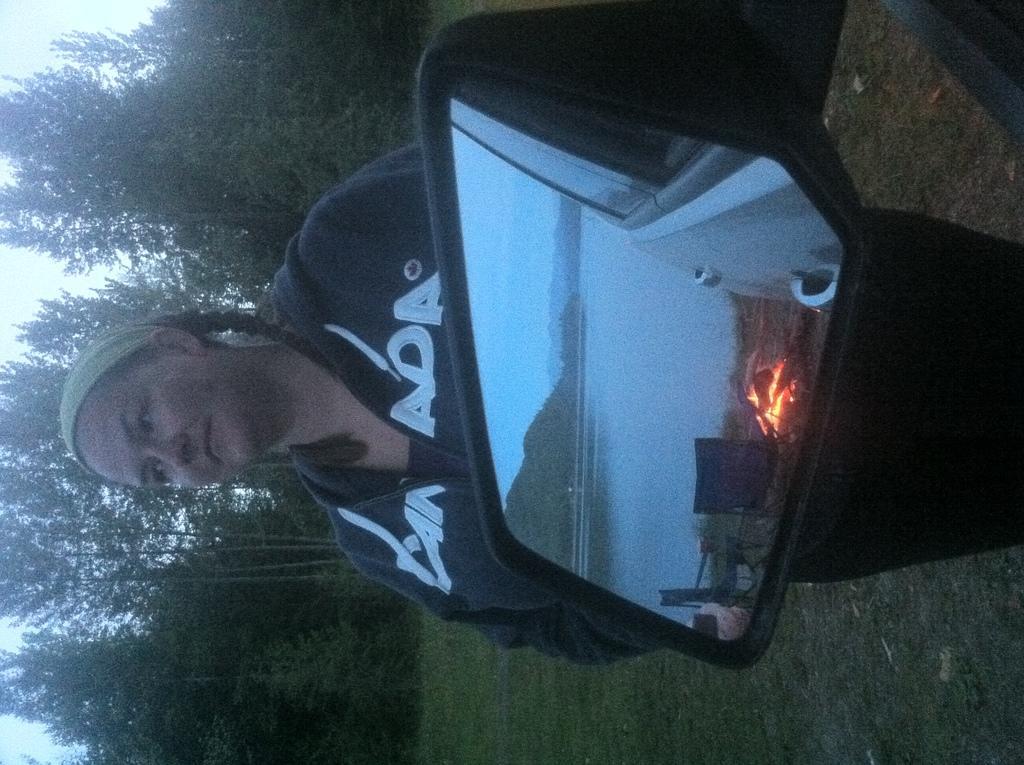Can you describe this image briefly? In this image in the front there is a mirror and on the mirror there are reflections of the fire, water and trees, and in the center there is a woman standing. In the background there are trees and there's grass on the ground. 